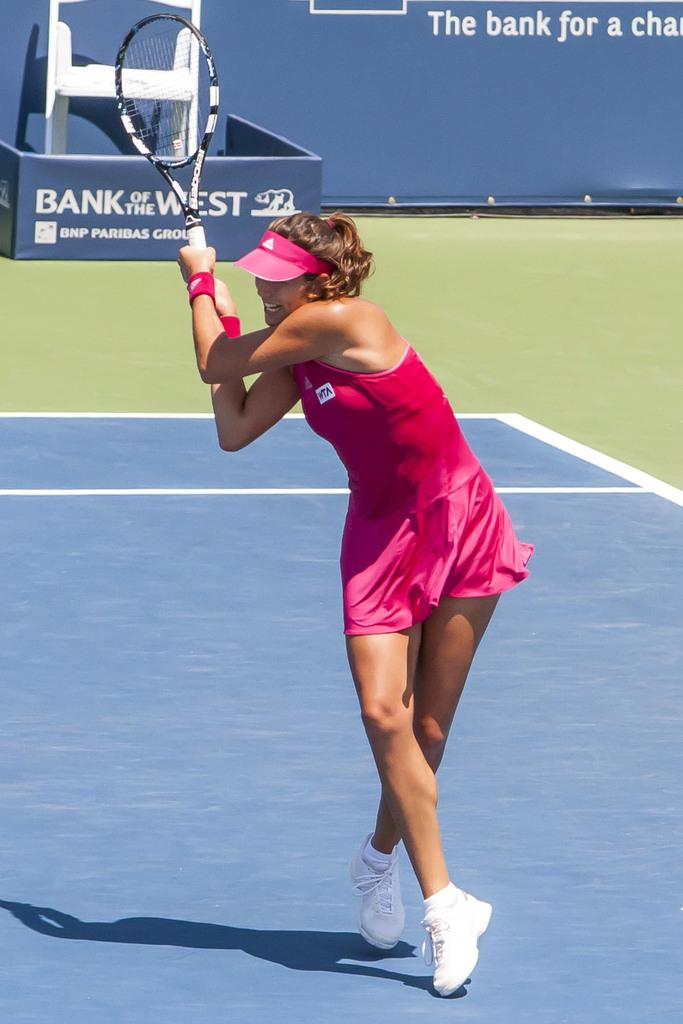What is the main subject of the image? The main subject of the image is a woman. What is the woman holding in her hand? The woman is holding a racket in her hand. What type of soap is the woman using to clean the flame in the image? There is no soap, flame, or cleaning activity present in the image. The woman is simply holding a racket. 